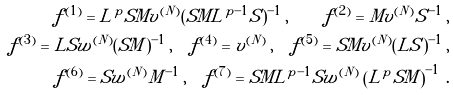<formula> <loc_0><loc_0><loc_500><loc_500>f ^ { ( 1 ) } = L ^ { p } S M v ^ { ( N ) } ( S M L ^ { p - 1 } S ) ^ { - 1 } \, , \quad f ^ { ( 2 ) } = M v ^ { ( N ) } S ^ { - 1 } \, , \\ f ^ { ( 3 ) } = L S w ^ { ( N ) } ( S M ) ^ { - 1 } \, , \quad f ^ { ( 4 ) } = v ^ { ( N ) } \, , \quad f ^ { ( 5 ) } = S M v ^ { ( N ) } ( L S ) ^ { - 1 } \, , \\ f ^ { ( 6 ) } = S w ^ { ( N ) } M ^ { - 1 } \, , \quad f ^ { ( 7 ) } = S M L ^ { p - 1 } S w ^ { ( N ) } \left ( L ^ { p } S M \right ) ^ { - 1 } \, .</formula> 